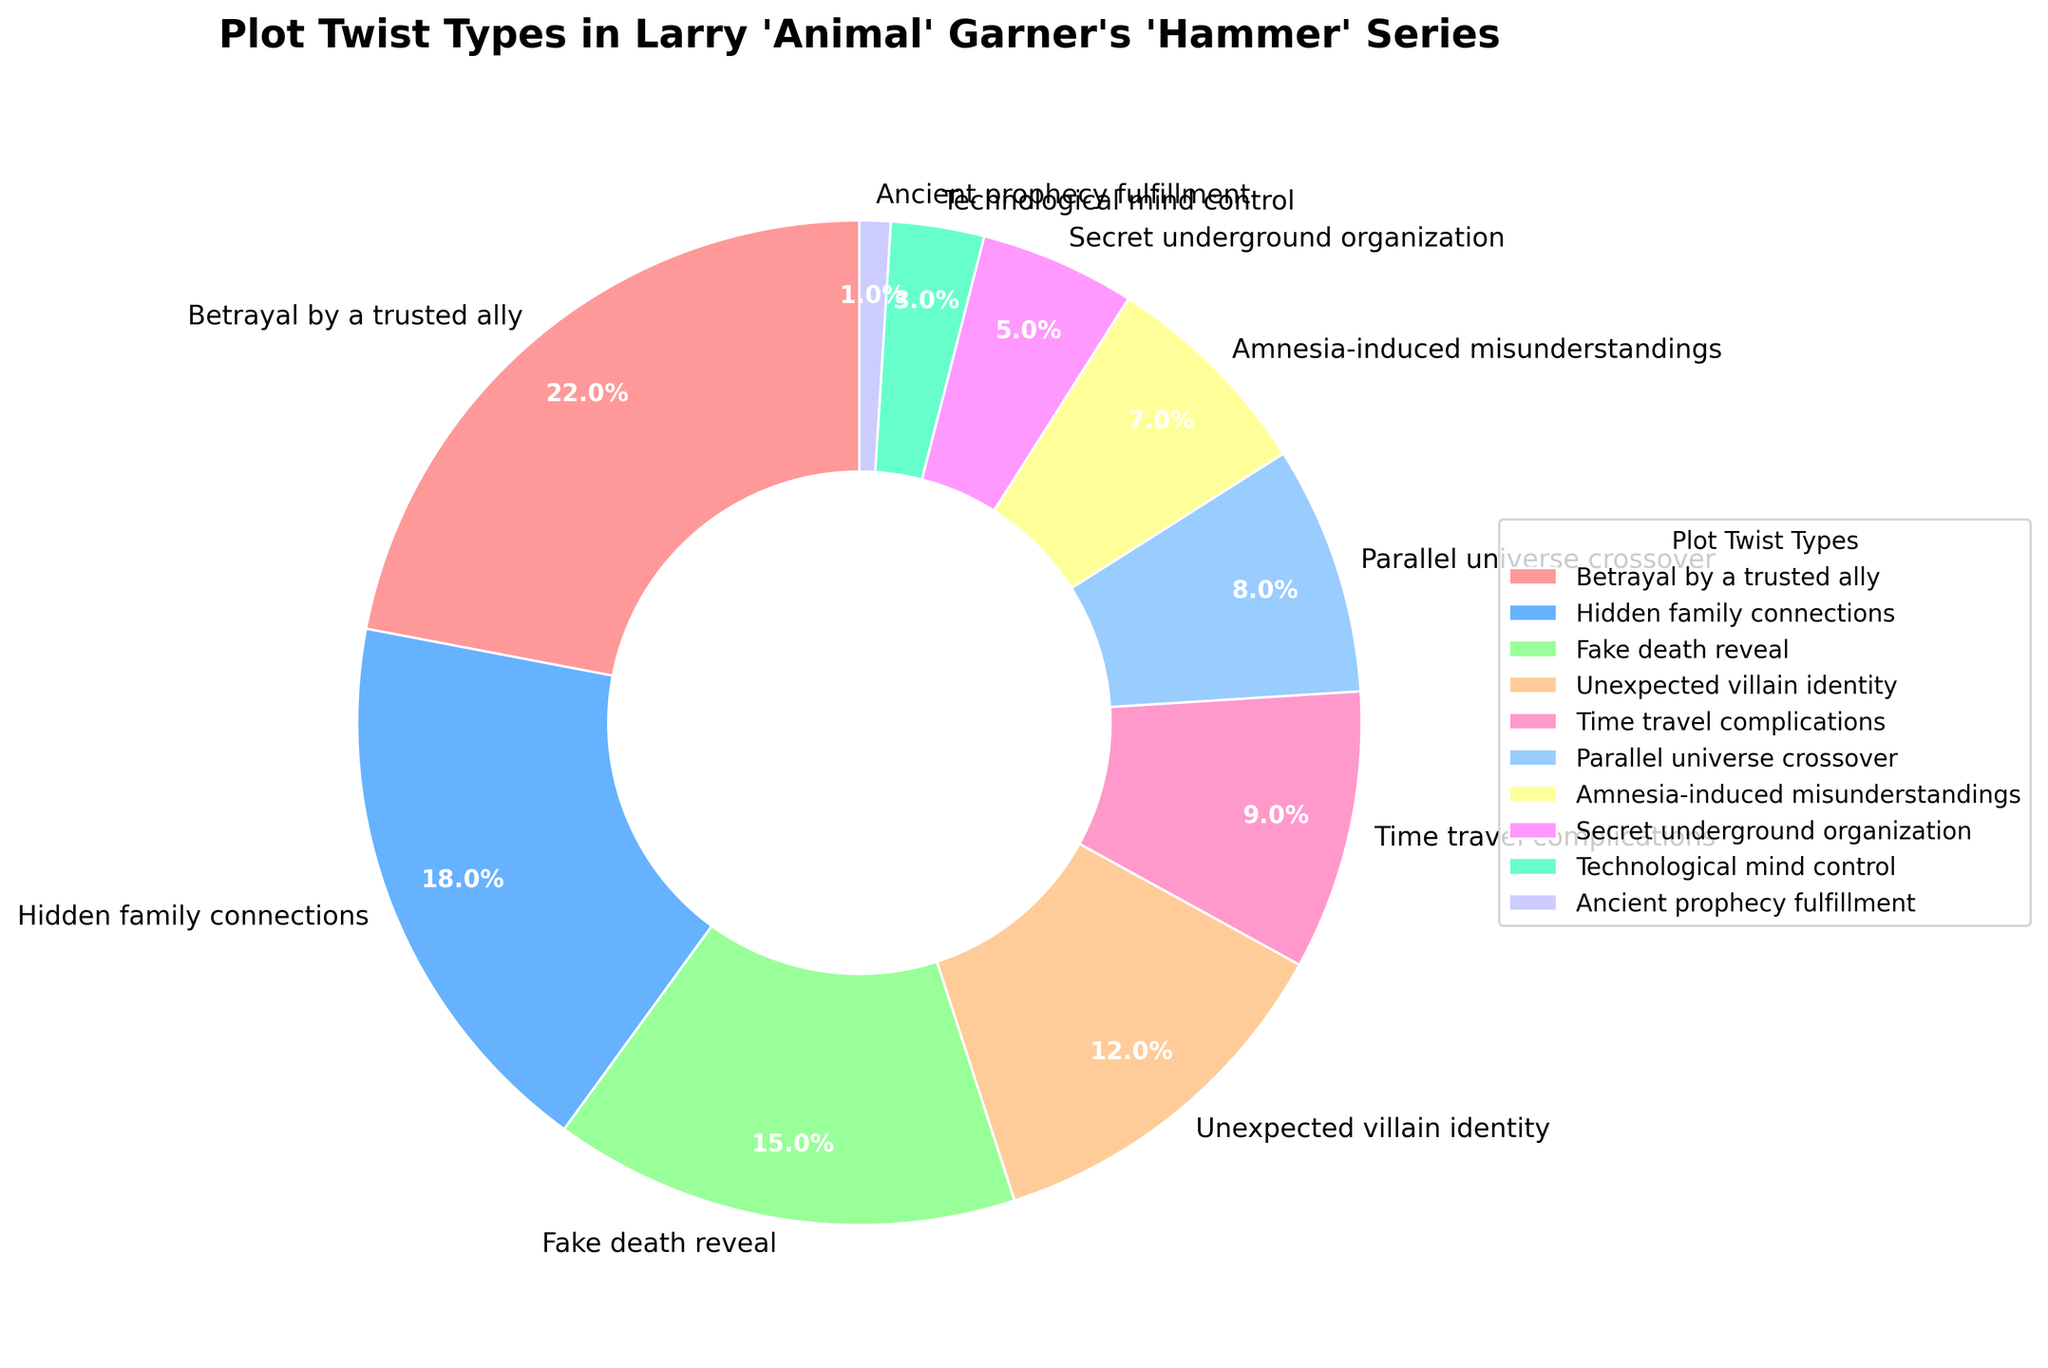What proportion of plot twists involve changes in a trusted ally's loyalty? The "Betrayal by a trusted ally" section occupies 22% of the pie chart, which depicts the proportion of different plot twists.
Answer: 22% Which plot twist type is the least common? The smallest section of the pie chart, with 1%, is "Ancient prophecy fulfillment."
Answer: Ancient prophecy fulfillment Do hidden family connections and fake death reveal combined occupy more or less than 40%? Hidden family connections occupy 18%, and fake death reveal occupies 15%. Combined, they make up 33%, which is less than 40%.
Answer: Less How much more common is the "Unexpected villain identity" twist compared to "Secret underground organization"? "Unexpected villain identity" holds 12%, while "Secret underground organization" holds 5%. The difference is 12% - 5% = 7%.
Answer: 7% Which plot twist is more frequent: "Time travel complications" or "Parallel universe crossover"? "Time travel complications" make up 9%, whereas "Parallel universe crossover" is 8%. "Time travel complications" is more frequent.
Answer: Time travel complications Is the proportion of "Technological mind control" less than a quarter of the proportion of "Betrayal by a trusted ally"? "Technological mind control" is 3%, and "Betrayal by a trusted ally" is 22%. One-quarter of 22% is 5.5%. Since 3% is less than 5.5%, the answer is yes.
Answer: Yes Which section is depicted with the lightest blue color? The lightest blue color segment represents "Parallel universe crossover" at 8%.
Answer: Parallel universe crossover What is the combined percentage of twists involving amnesia and technological mind control? "Amnesia-induced misunderstandings" are 7%, and "Technological mind control" is 3%. Combined, they are 7% + 3% = 10%.
Answer: 10% Order the plot twist types from most common to least common. The orders are: 1. Betrayal by a trusted ally (22%), 2. Hidden family connections (18%), 3. Fake death reveal (15%), 4. Unexpected villain identity (12%), 5. Time travel complications (9%), 6. Parallel universe crossover (8%), 7. Amnesia-induced misunderstandings (7%), 8. Secret underground organization (5%), 9. Technological mind control (3%), 10. Ancient prophecy fulfillment (1%).
Answer: Betrayal by a trusted ally, Hidden family connections, Fake death reveal, Unexpected villain identity, Time travel complications, Parallel universe crossover, Amnesia-induced misunderstandings, Secret underground organization, Technological mind control, Ancient prophecy fulfillment Which twist types combined make up exactly half of the total plot twists? "Betrayal by a trusted ally" (22%) and "Hidden family connections" (18%) together total 40%. Adding "Fake death reveal" (15%) brings it to 55%, which exceeds half. Thus, none of the twist types combine exactly to make up 50%.
Answer: None 